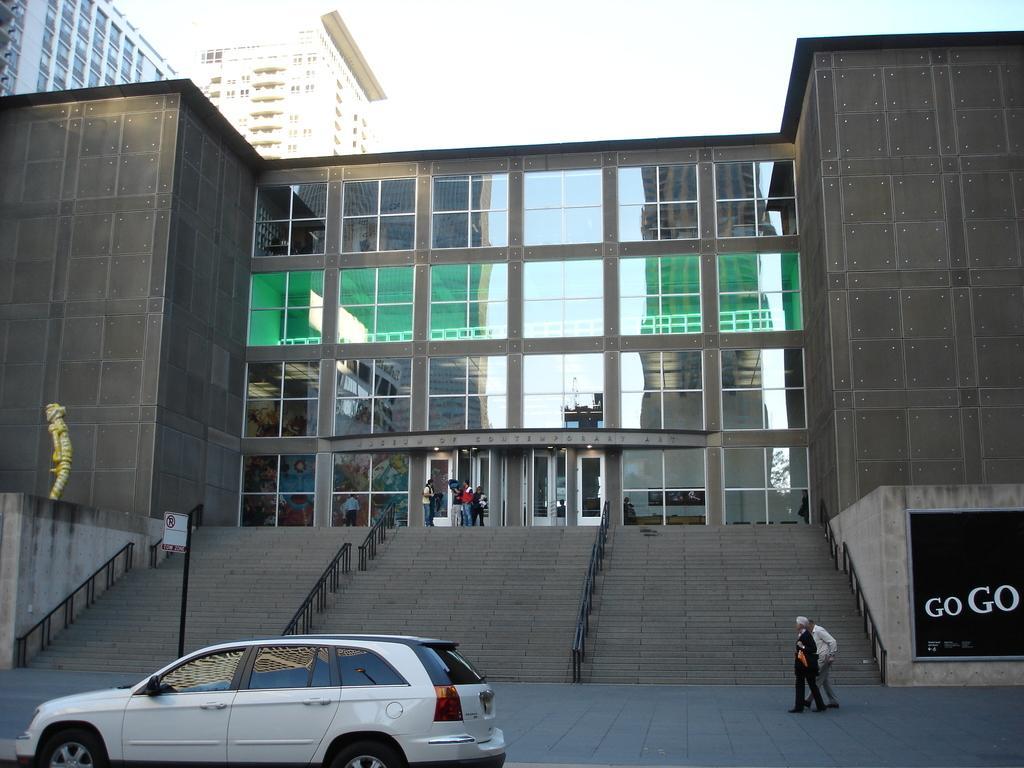Can you describe this image briefly? In the image we can see there are buildings and windows of the building, this is a sculpture, stairs, poster, vehicle and footpath. We can see there are even people wearing clothes, this is a pole. 